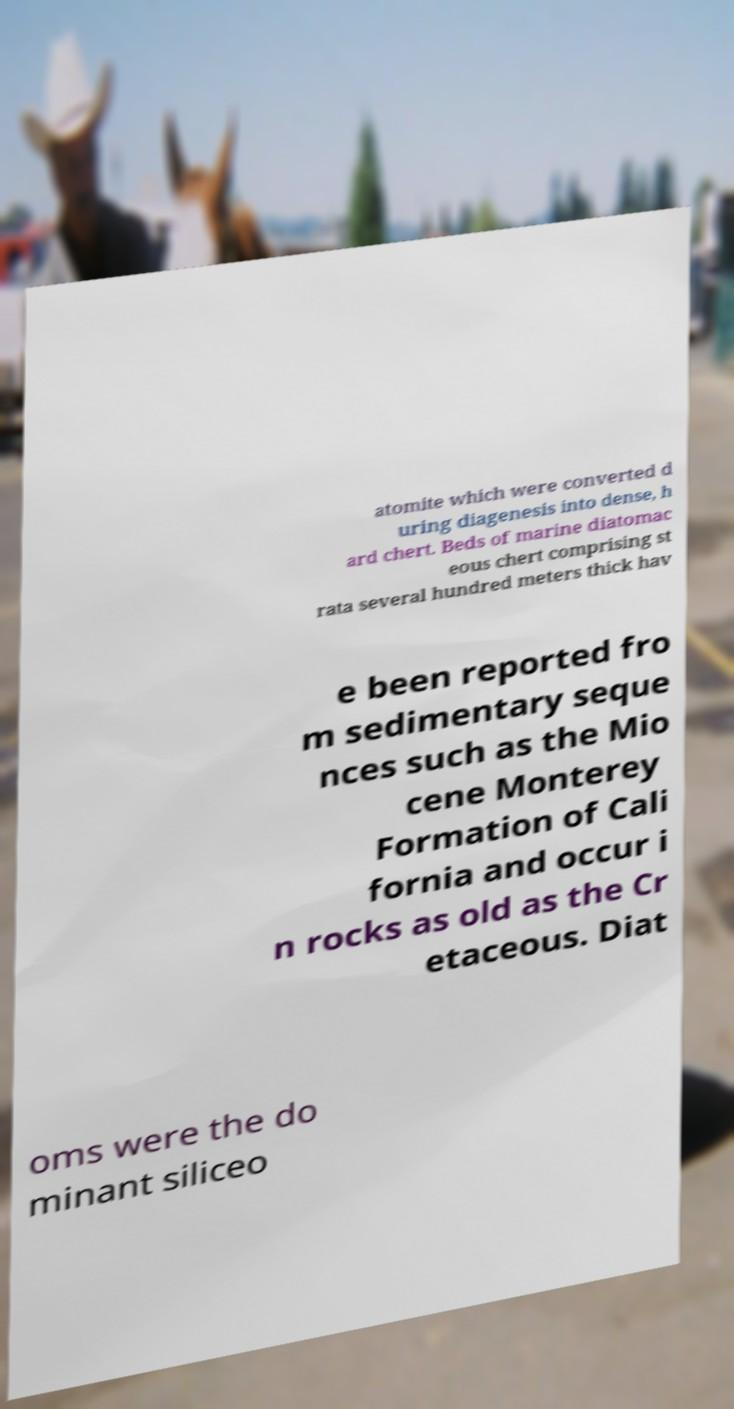For documentation purposes, I need the text within this image transcribed. Could you provide that? atomite which were converted d uring diagenesis into dense, h ard chert. Beds of marine diatomac eous chert comprising st rata several hundred meters thick hav e been reported fro m sedimentary seque nces such as the Mio cene Monterey Formation of Cali fornia and occur i n rocks as old as the Cr etaceous. Diat oms were the do minant siliceo 